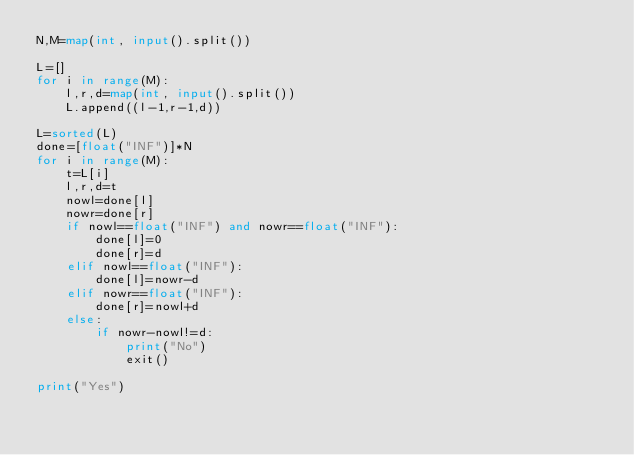<code> <loc_0><loc_0><loc_500><loc_500><_Python_>N,M=map(int, input().split())

L=[]
for i in range(M):
    l,r,d=map(int, input().split())
    L.append((l-1,r-1,d))

L=sorted(L)
done=[float("INF")]*N
for i in range(M):
    t=L[i]
    l,r,d=t
    nowl=done[l]
    nowr=done[r]
    if nowl==float("INF") and nowr==float("INF"):
        done[l]=0
        done[r]=d
    elif nowl==float("INF"):
        done[l]=nowr-d
    elif nowr==float("INF"):
        done[r]=nowl+d
    else:
        if nowr-nowl!=d:
            print("No")
            exit()

print("Yes")</code> 